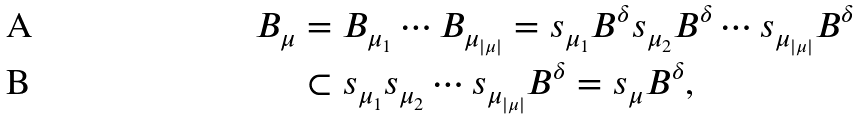<formula> <loc_0><loc_0><loc_500><loc_500>B _ { \mu } & = B _ { \mu _ { 1 } } \cdots B _ { \mu _ { | \mu | } } = s _ { \mu _ { 1 } } B ^ { \delta } s _ { \mu _ { 2 } } B ^ { \delta } \cdots s _ { \mu _ { | \mu | } } B ^ { \delta } \\ & \subset s _ { \mu _ { 1 } } s _ { \mu _ { 2 } } \cdots s _ { \mu _ { | \mu | } } B ^ { \delta } = s _ { \mu } B ^ { \delta } ,</formula> 